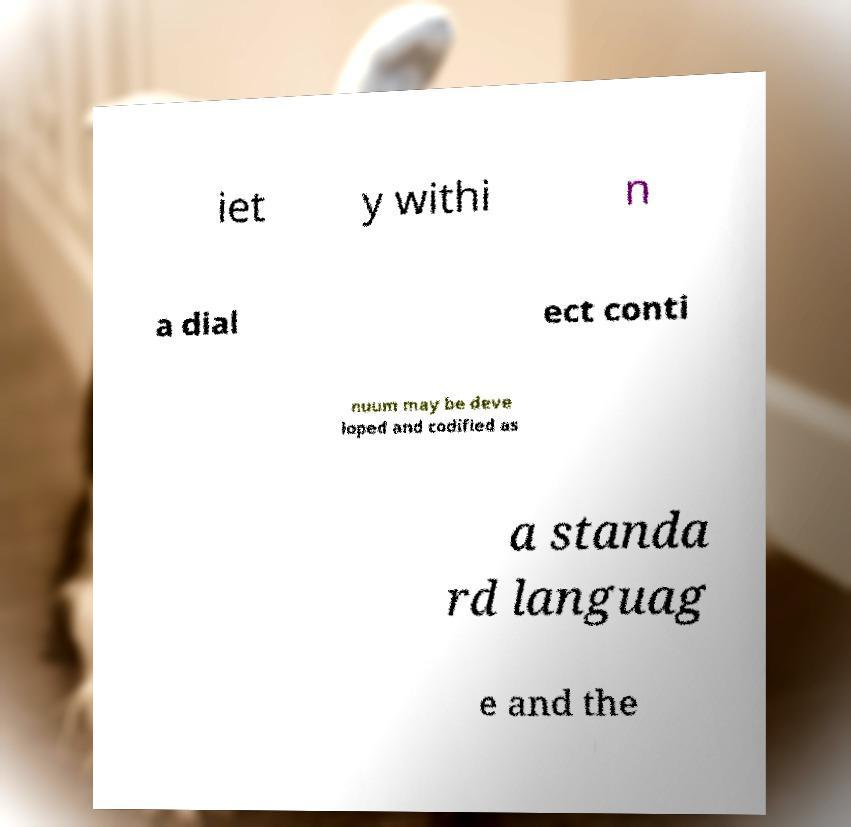There's text embedded in this image that I need extracted. Can you transcribe it verbatim? iet y withi n a dial ect conti nuum may be deve loped and codified as a standa rd languag e and the 